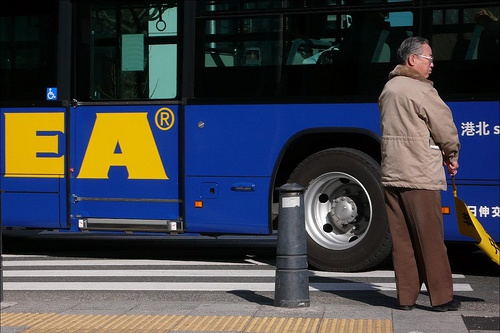Describe the objects in this image and their specific colors. I can see bus in black, darkblue, navy, and gold tones, people in black, maroon, darkgray, and gray tones, and people in black and teal tones in this image. 